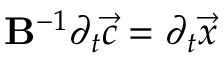Convert formula to latex. <formula><loc_0><loc_0><loc_500><loc_500>B ^ { - 1 } \partial _ { t } \vec { c } = \partial _ { t } \vec { x }</formula> 